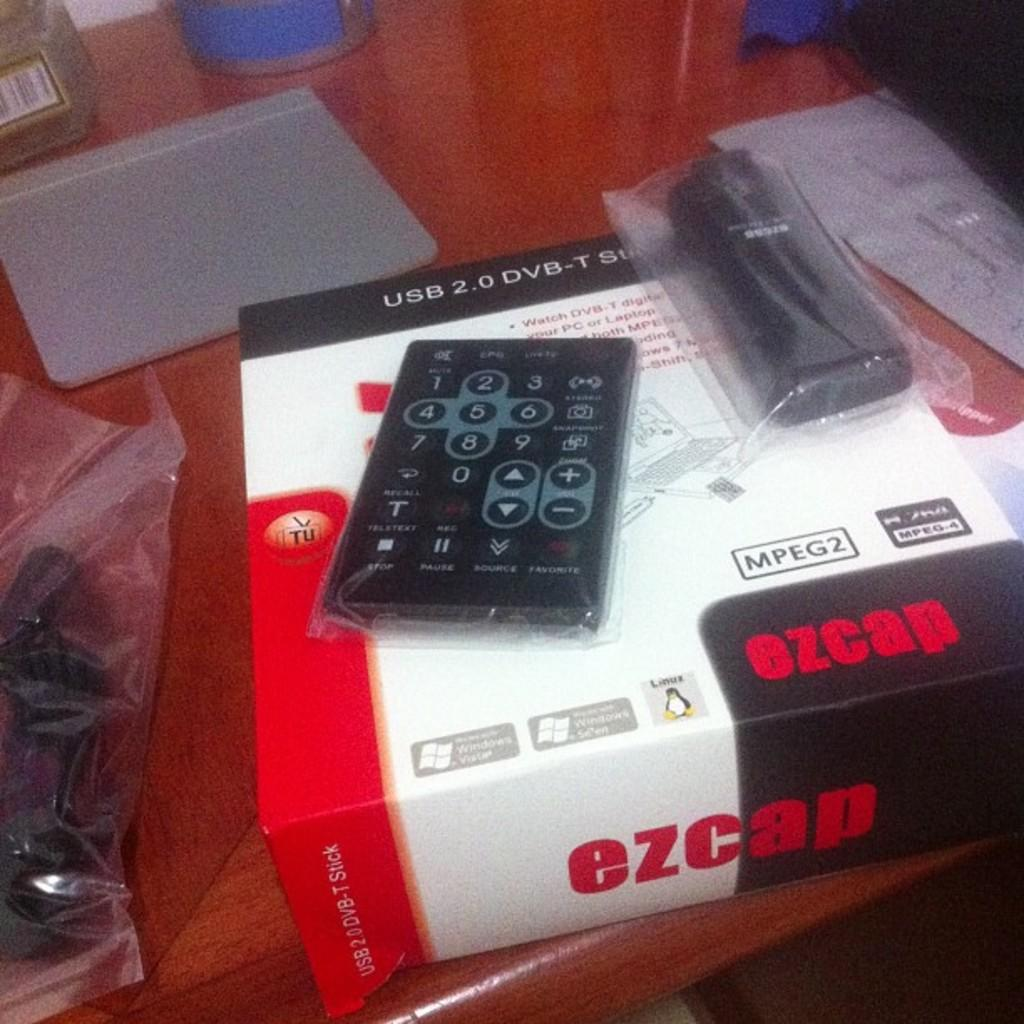<image>
Present a compact description of the photo's key features. An EZCAP DVB player box with the remote on the top of the box, it is placed on a desk 